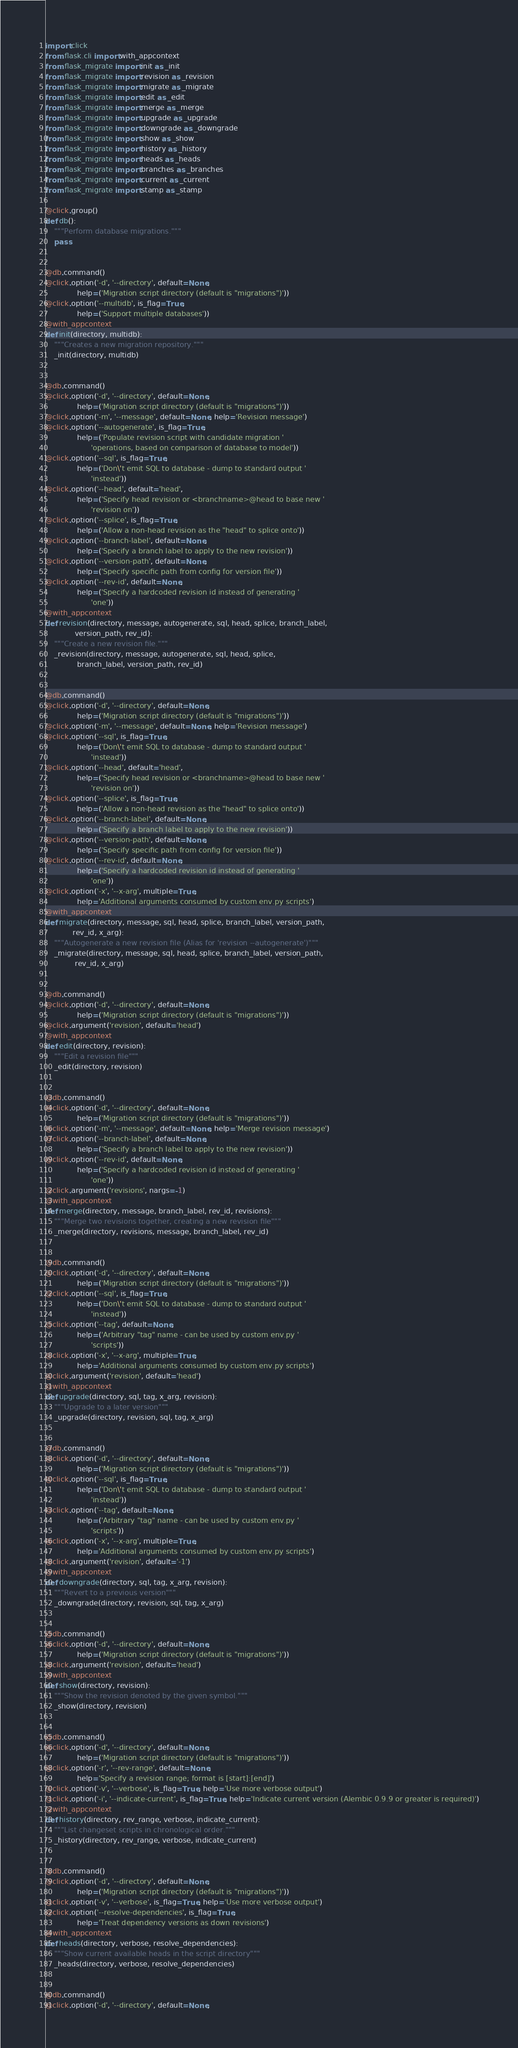Convert code to text. <code><loc_0><loc_0><loc_500><loc_500><_Python_>import click
from flask.cli import with_appcontext
from flask_migrate import init as _init
from flask_migrate import revision as _revision
from flask_migrate import migrate as _migrate
from flask_migrate import edit as _edit
from flask_migrate import merge as _merge
from flask_migrate import upgrade as _upgrade
from flask_migrate import downgrade as _downgrade
from flask_migrate import show as _show
from flask_migrate import history as _history
from flask_migrate import heads as _heads
from flask_migrate import branches as _branches
from flask_migrate import current as _current
from flask_migrate import stamp as _stamp

@click.group()
def db():
    """Perform database migrations."""
    pass


@db.command()
@click.option('-d', '--directory', default=None,
              help=('Migration script directory (default is "migrations")'))
@click.option('--multidb', is_flag=True,
              help=('Support multiple databases'))
@with_appcontext
def init(directory, multidb):
    """Creates a new migration repository."""
    _init(directory, multidb)


@db.command()
@click.option('-d', '--directory', default=None,
              help=('Migration script directory (default is "migrations")'))
@click.option('-m', '--message', default=None, help='Revision message')
@click.option('--autogenerate', is_flag=True,
              help=('Populate revision script with candidate migration '
                    'operations, based on comparison of database to model'))
@click.option('--sql', is_flag=True,
              help=('Don\'t emit SQL to database - dump to standard output '
                    'instead'))
@click.option('--head', default='head',
              help=('Specify head revision or <branchname>@head to base new '
                    'revision on'))
@click.option('--splice', is_flag=True,
              help=('Allow a non-head revision as the "head" to splice onto'))
@click.option('--branch-label', default=None,
              help=('Specify a branch label to apply to the new revision'))
@click.option('--version-path', default=None,
              help=('Specify specific path from config for version file'))
@click.option('--rev-id', default=None,
              help=('Specify a hardcoded revision id instead of generating '
                    'one'))
@with_appcontext
def revision(directory, message, autogenerate, sql, head, splice, branch_label,
             version_path, rev_id):
    """Create a new revision file."""
    _revision(directory, message, autogenerate, sql, head, splice,
              branch_label, version_path, rev_id)


@db.command()
@click.option('-d', '--directory', default=None,
              help=('Migration script directory (default is "migrations")'))
@click.option('-m', '--message', default=None, help='Revision message')
@click.option('--sql', is_flag=True,
              help=('Don\'t emit SQL to database - dump to standard output '
                    'instead'))
@click.option('--head', default='head',
              help=('Specify head revision or <branchname>@head to base new '
                    'revision on'))
@click.option('--splice', is_flag=True,
              help=('Allow a non-head revision as the "head" to splice onto'))
@click.option('--branch-label', default=None,
              help=('Specify a branch label to apply to the new revision'))
@click.option('--version-path', default=None,
              help=('Specify specific path from config for version file'))
@click.option('--rev-id', default=None,
              help=('Specify a hardcoded revision id instead of generating '
                    'one'))
@click.option('-x', '--x-arg', multiple=True,
              help='Additional arguments consumed by custom env.py scripts')
@with_appcontext
def migrate(directory, message, sql, head, splice, branch_label, version_path,
            rev_id, x_arg):
    """Autogenerate a new revision file (Alias for 'revision --autogenerate')"""
    _migrate(directory, message, sql, head, splice, branch_label, version_path,
             rev_id, x_arg)


@db.command()
@click.option('-d', '--directory', default=None,
              help=('Migration script directory (default is "migrations")'))
@click.argument('revision', default='head')
@with_appcontext
def edit(directory, revision):
    """Edit a revision file"""
    _edit(directory, revision)


@db.command()
@click.option('-d', '--directory', default=None,
              help=('Migration script directory (default is "migrations")'))
@click.option('-m', '--message', default=None, help='Merge revision message')
@click.option('--branch-label', default=None,
              help=('Specify a branch label to apply to the new revision'))
@click.option('--rev-id', default=None,
              help=('Specify a hardcoded revision id instead of generating '
                    'one'))
@click.argument('revisions', nargs=-1)
@with_appcontext
def merge(directory, message, branch_label, rev_id, revisions):
    """Merge two revisions together, creating a new revision file"""
    _merge(directory, revisions, message, branch_label, rev_id)


@db.command()
@click.option('-d', '--directory', default=None,
              help=('Migration script directory (default is "migrations")'))
@click.option('--sql', is_flag=True,
              help=('Don\'t emit SQL to database - dump to standard output '
                    'instead'))
@click.option('--tag', default=None,
              help=('Arbitrary "tag" name - can be used by custom env.py '
                    'scripts'))
@click.option('-x', '--x-arg', multiple=True,
              help='Additional arguments consumed by custom env.py scripts')
@click.argument('revision', default='head')
@with_appcontext
def upgrade(directory, sql, tag, x_arg, revision):
    """Upgrade to a later version"""
    _upgrade(directory, revision, sql, tag, x_arg)


@db.command()
@click.option('-d', '--directory', default=None,
              help=('Migration script directory (default is "migrations")'))
@click.option('--sql', is_flag=True,
              help=('Don\'t emit SQL to database - dump to standard output '
                    'instead'))
@click.option('--tag', default=None,
              help=('Arbitrary "tag" name - can be used by custom env.py '
                    'scripts'))
@click.option('-x', '--x-arg', multiple=True,
              help='Additional arguments consumed by custom env.py scripts')
@click.argument('revision', default='-1')
@with_appcontext
def downgrade(directory, sql, tag, x_arg, revision):
    """Revert to a previous version"""
    _downgrade(directory, revision, sql, tag, x_arg)


@db.command()
@click.option('-d', '--directory', default=None,
              help=('Migration script directory (default is "migrations")'))
@click.argument('revision', default='head')
@with_appcontext
def show(directory, revision):
    """Show the revision denoted by the given symbol."""
    _show(directory, revision)


@db.command()
@click.option('-d', '--directory', default=None,
              help=('Migration script directory (default is "migrations")'))
@click.option('-r', '--rev-range', default=None,
              help='Specify a revision range; format is [start]:[end]')
@click.option('-v', '--verbose', is_flag=True, help='Use more verbose output')
@click.option('-i', '--indicate-current', is_flag=True, help='Indicate current version (Alembic 0.9.9 or greater is required)')
@with_appcontext
def history(directory, rev_range, verbose, indicate_current):
    """List changeset scripts in chronological order."""
    _history(directory, rev_range, verbose, indicate_current)


@db.command()
@click.option('-d', '--directory', default=None,
              help=('Migration script directory (default is "migrations")'))
@click.option('-v', '--verbose', is_flag=True, help='Use more verbose output')
@click.option('--resolve-dependencies', is_flag=True,
              help='Treat dependency versions as down revisions')
@with_appcontext
def heads(directory, verbose, resolve_dependencies):
    """Show current available heads in the script directory"""
    _heads(directory, verbose, resolve_dependencies)


@db.command()
@click.option('-d', '--directory', default=None,</code> 